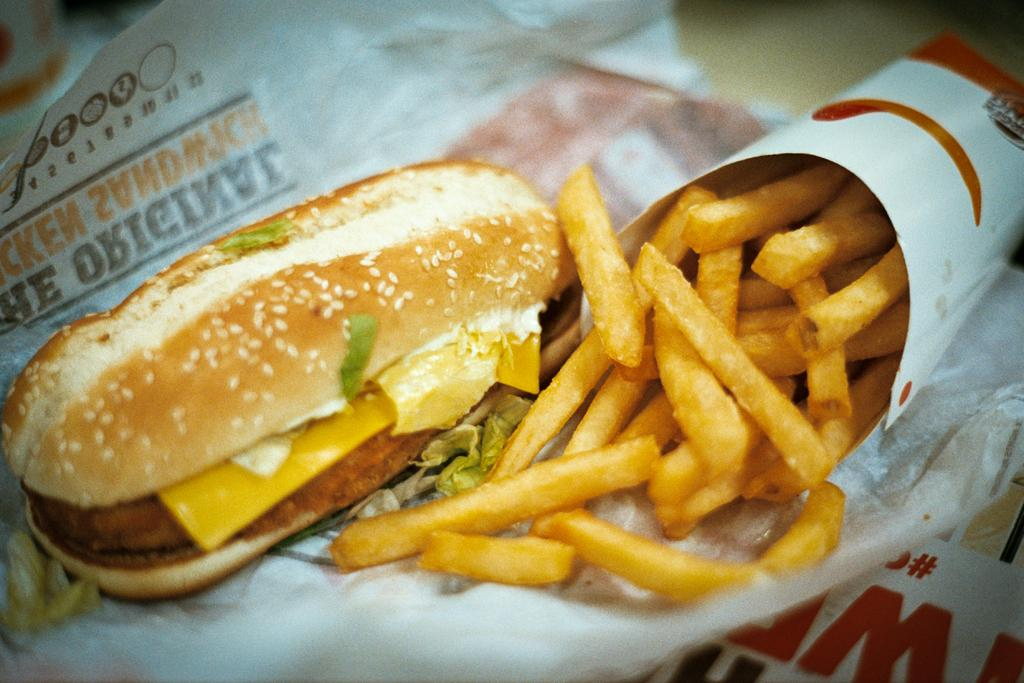What type of food is in the paper-cone in the image? There are french-fries in a paper-cone in the image. What other food item is present in the image? There is a burger on a paper in the image. What is the surface on which the french-fries and burger are placed? The french-fries and burger are on a cream-colored surface. What story is being told by the french-fries and burger in the image? There is no story being told by the french-fries and burger in the image; they are simply food items on a surface. What color is the burger in the image? The provided facts do not mention the color of the burger, so it cannot be determined from the image. 